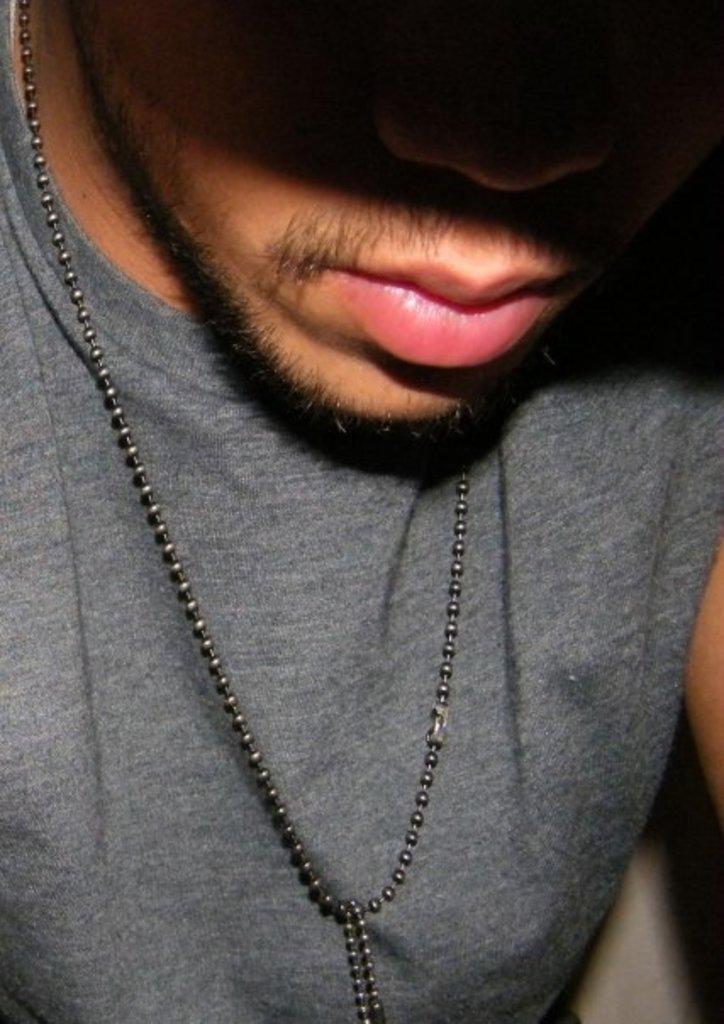In one or two sentences, can you explain what this image depicts? In this image we can see a man and there is a chain to his neck. 